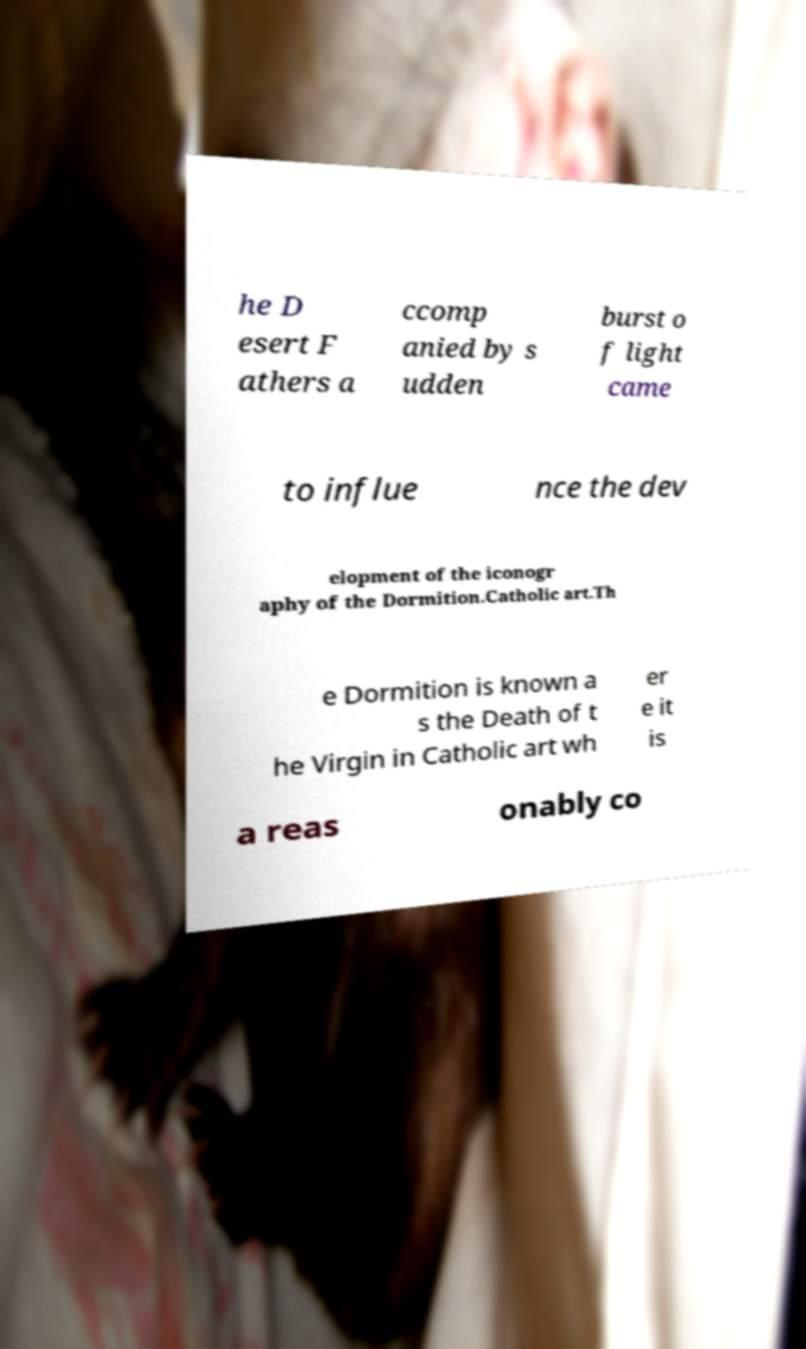I need the written content from this picture converted into text. Can you do that? he D esert F athers a ccomp anied by s udden burst o f light came to influe nce the dev elopment of the iconogr aphy of the Dormition.Catholic art.Th e Dormition is known a s the Death of t he Virgin in Catholic art wh er e it is a reas onably co 